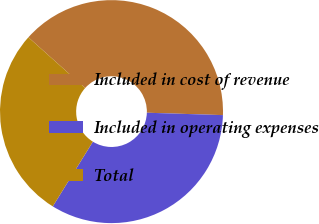Convert chart. <chart><loc_0><loc_0><loc_500><loc_500><pie_chart><fcel>Included in cost of revenue<fcel>Included in operating expenses<fcel>Total<nl><fcel>38.89%<fcel>33.33%<fcel>27.78%<nl></chart> 